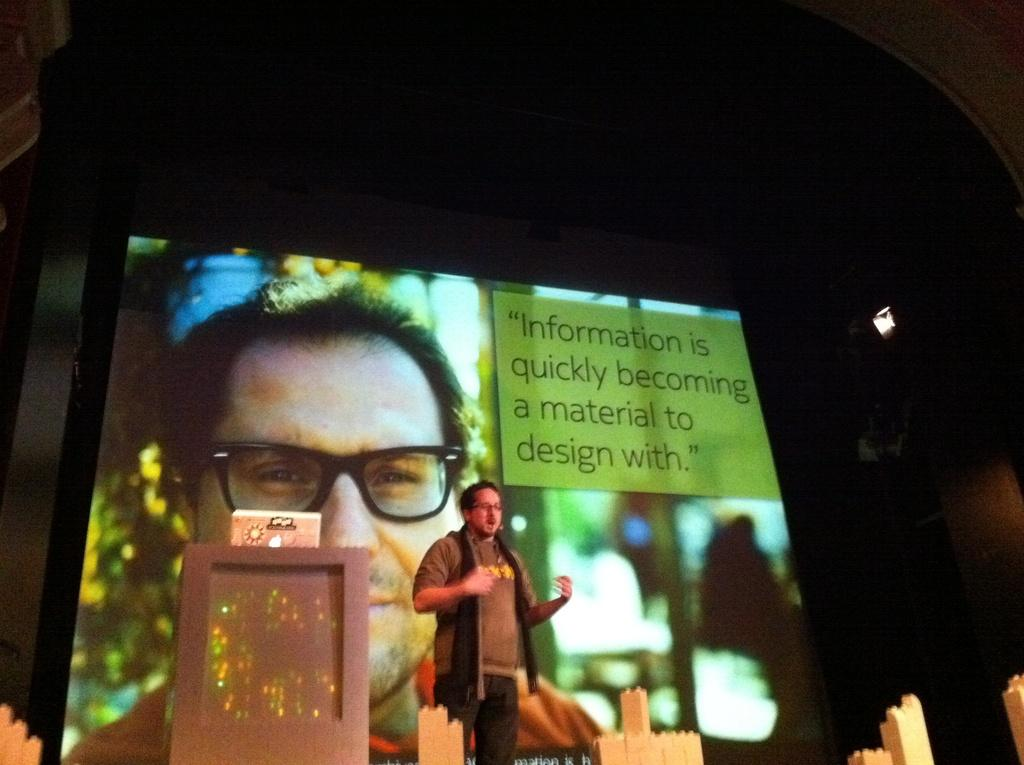What is the main subject of the image? The main subject of the image is a man standing. Can you describe the man's appearance? The man is wearing clothes and spectacles. What might the man be doing in the image? It appears that the man is talking. What objects are present in the image? There is a podium and a projected screen in the image. How would you describe the background of the image? The background of the image is dark. What type of tank can be seen in the image? There is no tank present in the image. How many balloons are being held by the man in the image? There are no balloons visible in the image. 